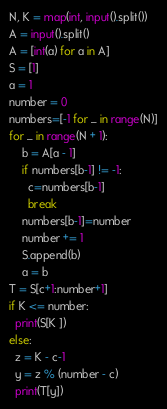<code> <loc_0><loc_0><loc_500><loc_500><_Python_>N, K = map(int, input().split())
A = input().split()
A = [int(a) for a in A]
S = [1]
a = 1
number = 0
numbers=[-1 for _ in range(N)]
for _ in range(N + 1):
    b = A[a - 1]
    if numbers[b-1] != -1:
      c=numbers[b-1]
      break
    numbers[b-1]=number
    number += 1
    S.append(b)
    a = b
T = S[c+1:number+1]
if K <= number:
  print(S[K ])
else:
  z = K - c-1
  y = z % (number - c)
  print(T[y])

</code> 